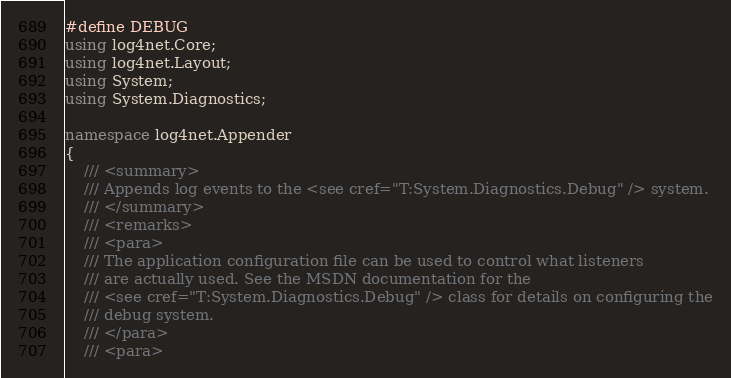<code> <loc_0><loc_0><loc_500><loc_500><_C#_>#define DEBUG
using log4net.Core;
using log4net.Layout;
using System;
using System.Diagnostics;

namespace log4net.Appender
{
	/// <summary>
	/// Appends log events to the <see cref="T:System.Diagnostics.Debug" /> system.
	/// </summary>
	/// <remarks>
	/// <para>
	/// The application configuration file can be used to control what listeners 
	/// are actually used. See the MSDN documentation for the 
	/// <see cref="T:System.Diagnostics.Debug" /> class for details on configuring the
	/// debug system.
	/// </para>
	/// <para></code> 